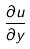Convert formula to latex. <formula><loc_0><loc_0><loc_500><loc_500>\frac { \partial u } { \partial y }</formula> 